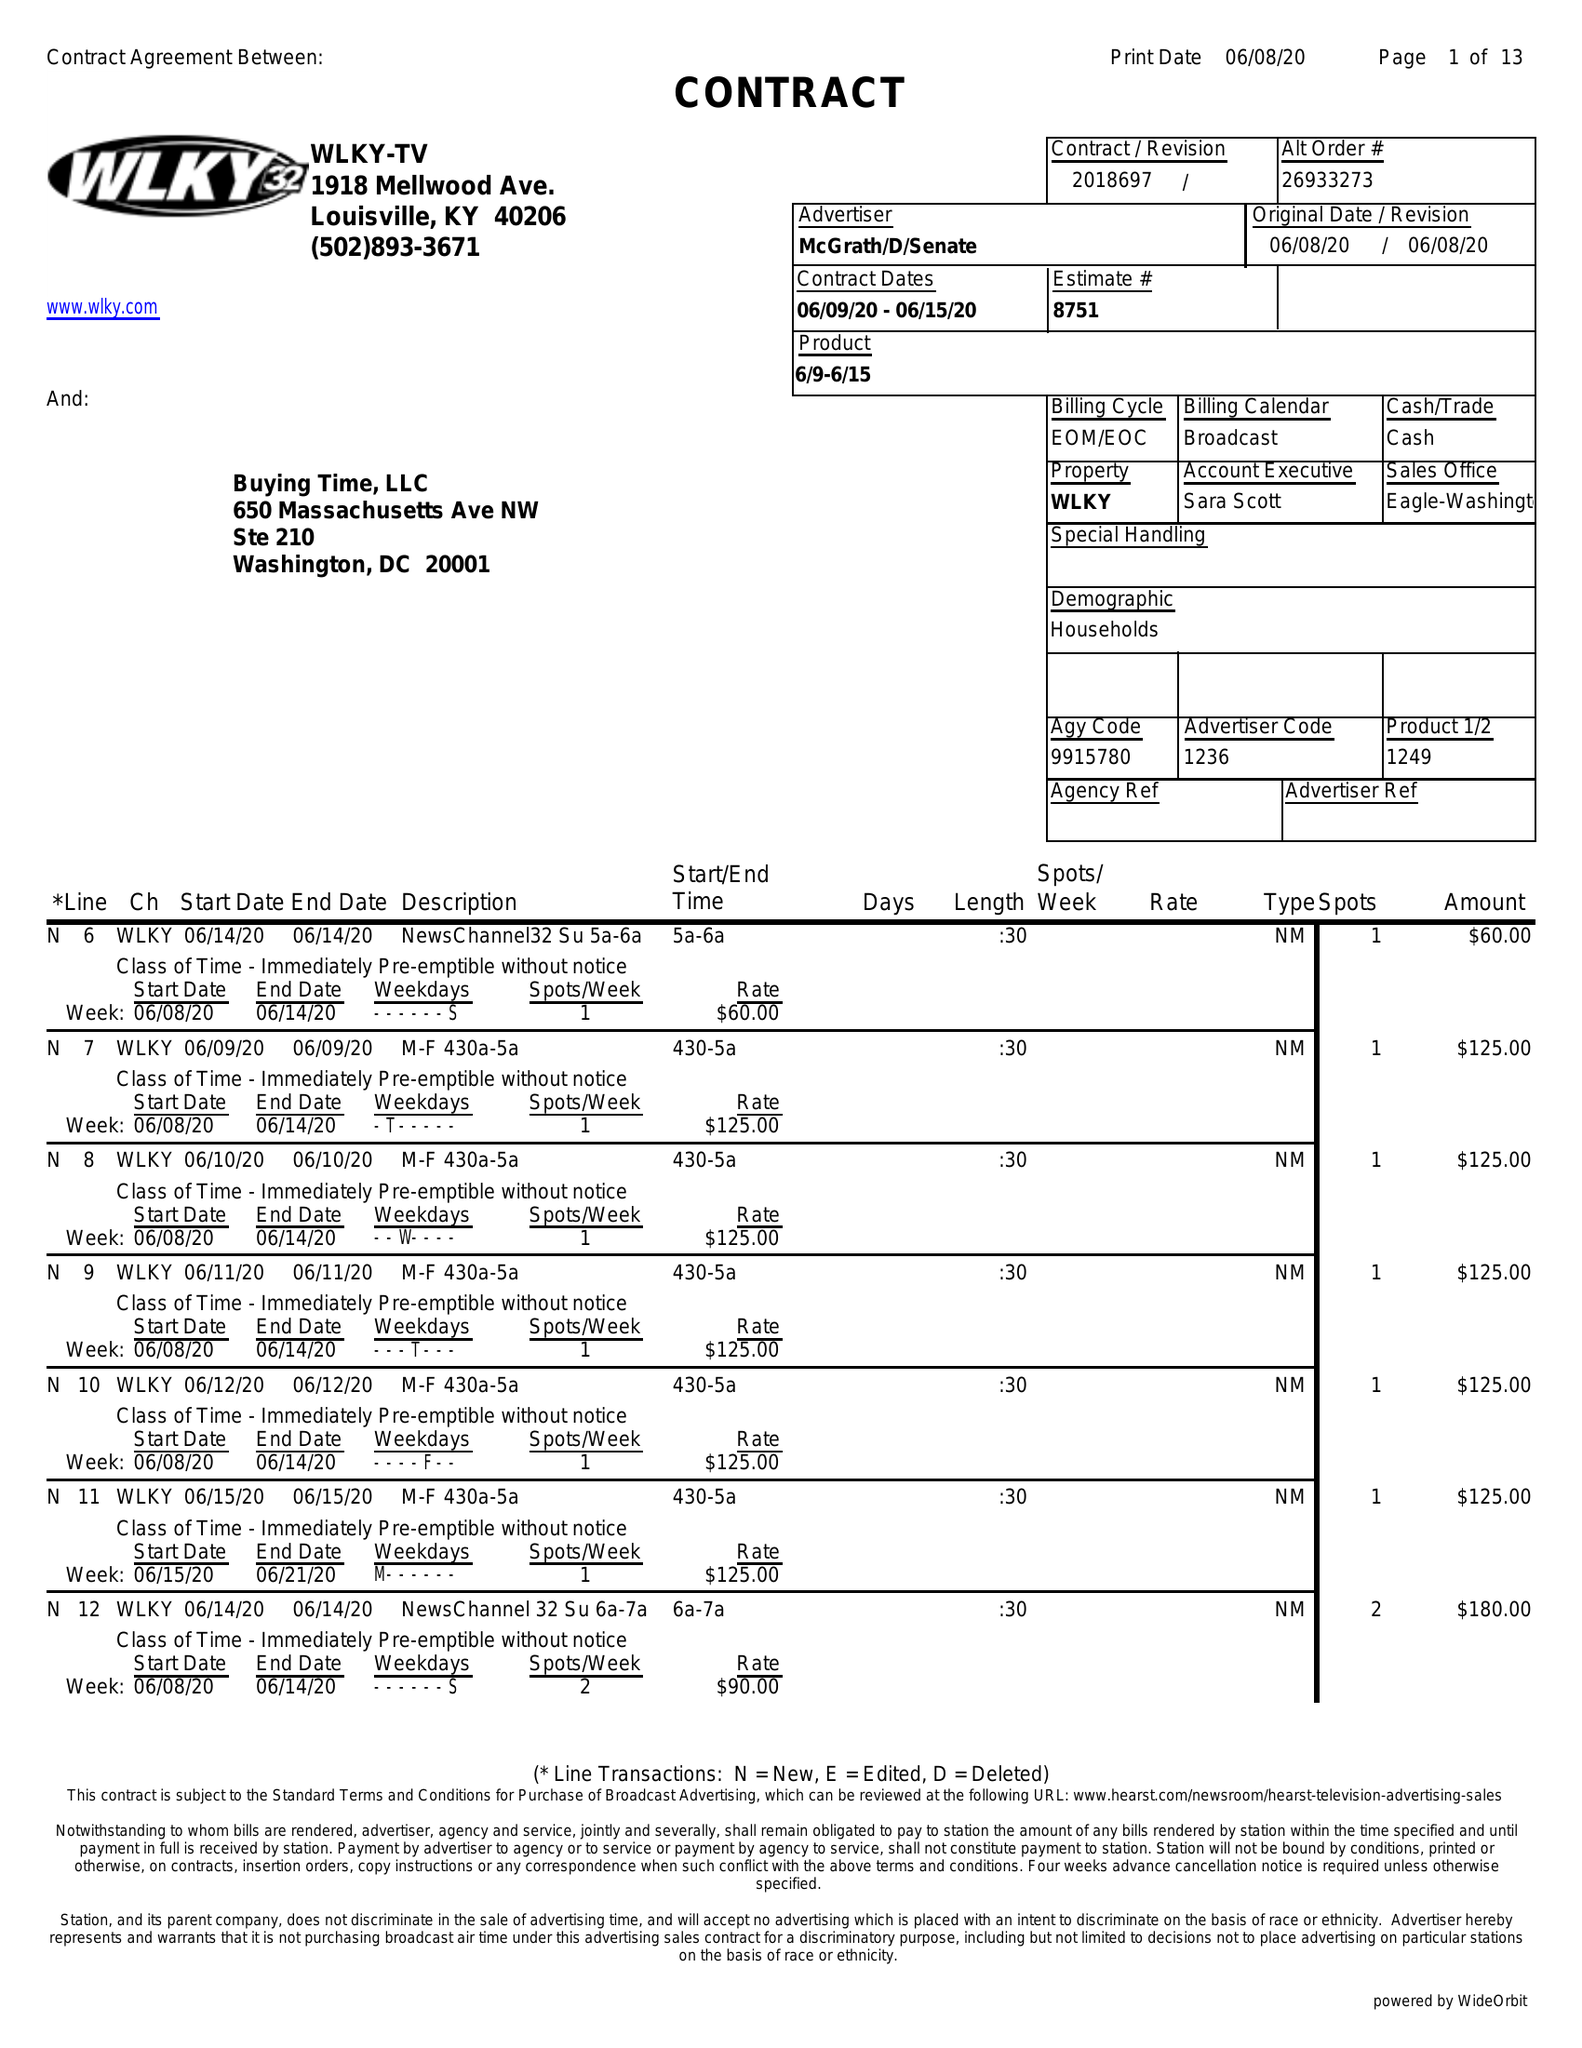What is the value for the gross_amount?
Answer the question using a single word or phrase. 30645.00 